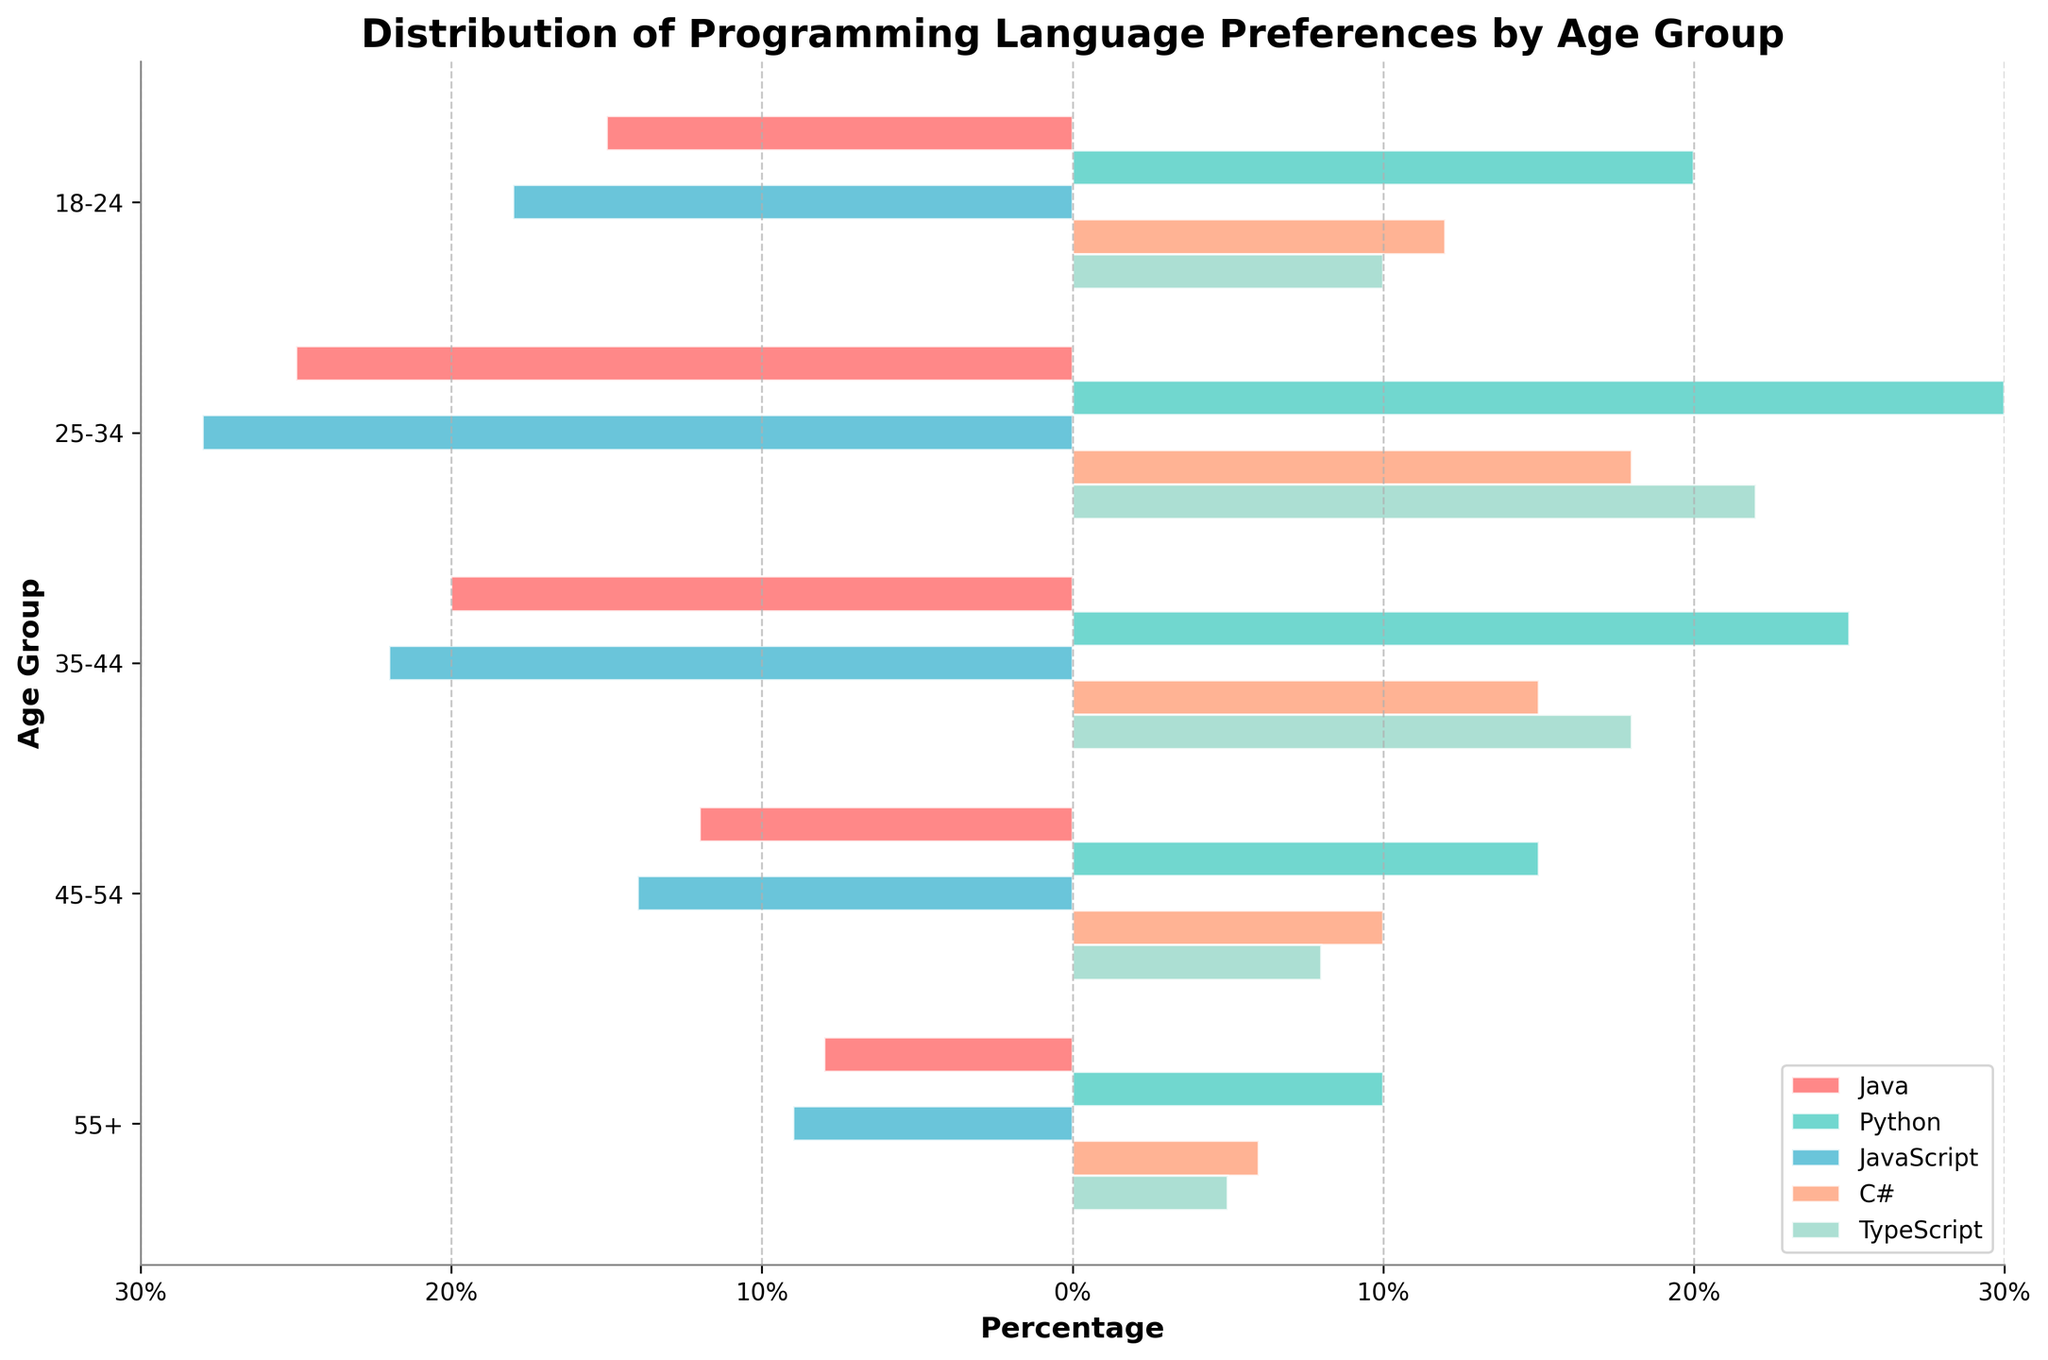What's the title of the figure? The title of the figure is typically found at the top-center and usually in a larger font size. In this case, it summarizes the figure's main topic.
Answer: Distribution of Programming Language Preferences by Age Group Which age group has the highest percentage for Python? By observing the horizontal bars representing Python's percentage in each age group, the age group with the longest bar will indicate the highest percentage.
Answer: 25-34 How does the popularity of TypeScript change as age increases? By observing the horizontal bars for TypeScript across different age groups, note how its length changes with age progression. The bars get shorter as we move from younger to older age groups.
Answer: Decreases What's the average percentage for C# across all age groups? Sum the percentages of C# across all age groups and then divide by the number of groups: (12 + 18 + 15 + 10 + 6) / 5 = 61 / 5.
Answer: 12.2% Which programming languages have a higher percentage in the 25-34 age group compared to the 35-44 age group? Compare the percentages for each language between the 25-34 and 35-44 age groups. Python, JavaScript, C#, and TypeScript have higher values in the 25-34 group than in the 35-44 group.
Answer: Python, JavaScript, C#, TypeScript In which age group is C# most preferred? Look for the age group with the longest horizontal bar for C#. The 25-34 age group has the highest bar for C#, representing the maximum percentage.
Answer: 25-34 